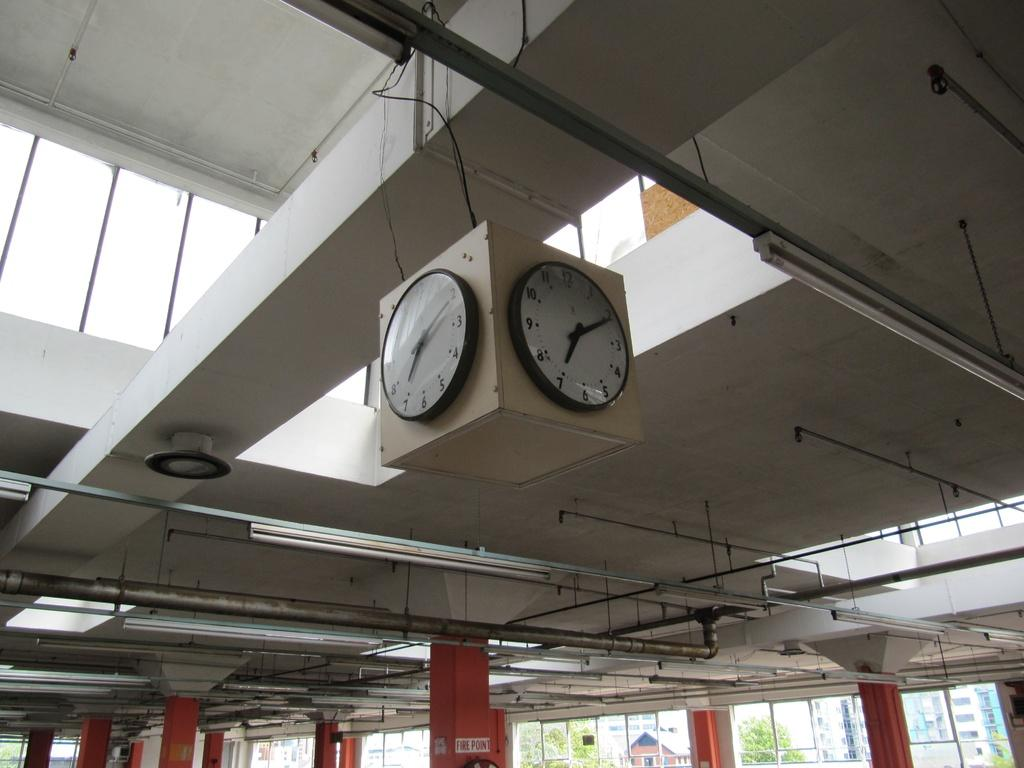<image>
Write a terse but informative summary of the picture. A business or warehouse ceiling features a clock that reads 7:12. 